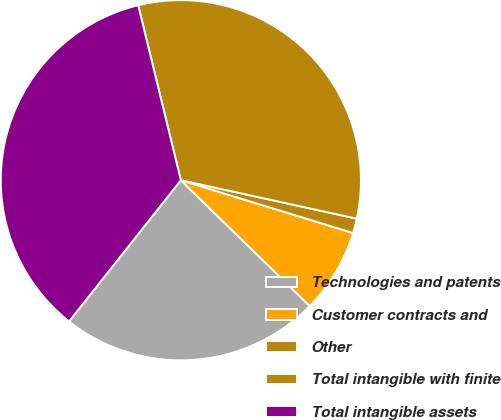Convert chart to OTSL. <chart><loc_0><loc_0><loc_500><loc_500><pie_chart><fcel>Technologies and patents<fcel>Customer contracts and<fcel>Other<fcel>Total intangible with finite<fcel>Total intangible assets<nl><fcel>23.35%<fcel>7.57%<fcel>1.31%<fcel>32.23%<fcel>35.53%<nl></chart> 